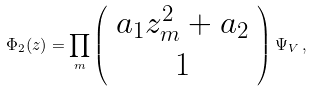<formula> <loc_0><loc_0><loc_500><loc_500>\Phi _ { 2 } ( z ) = \prod _ { m } \left ( \begin{array} { c } a _ { 1 } z _ { m } ^ { 2 } + a _ { 2 } \\ 1 \end{array} \right ) \Psi _ { V } \, ,</formula> 